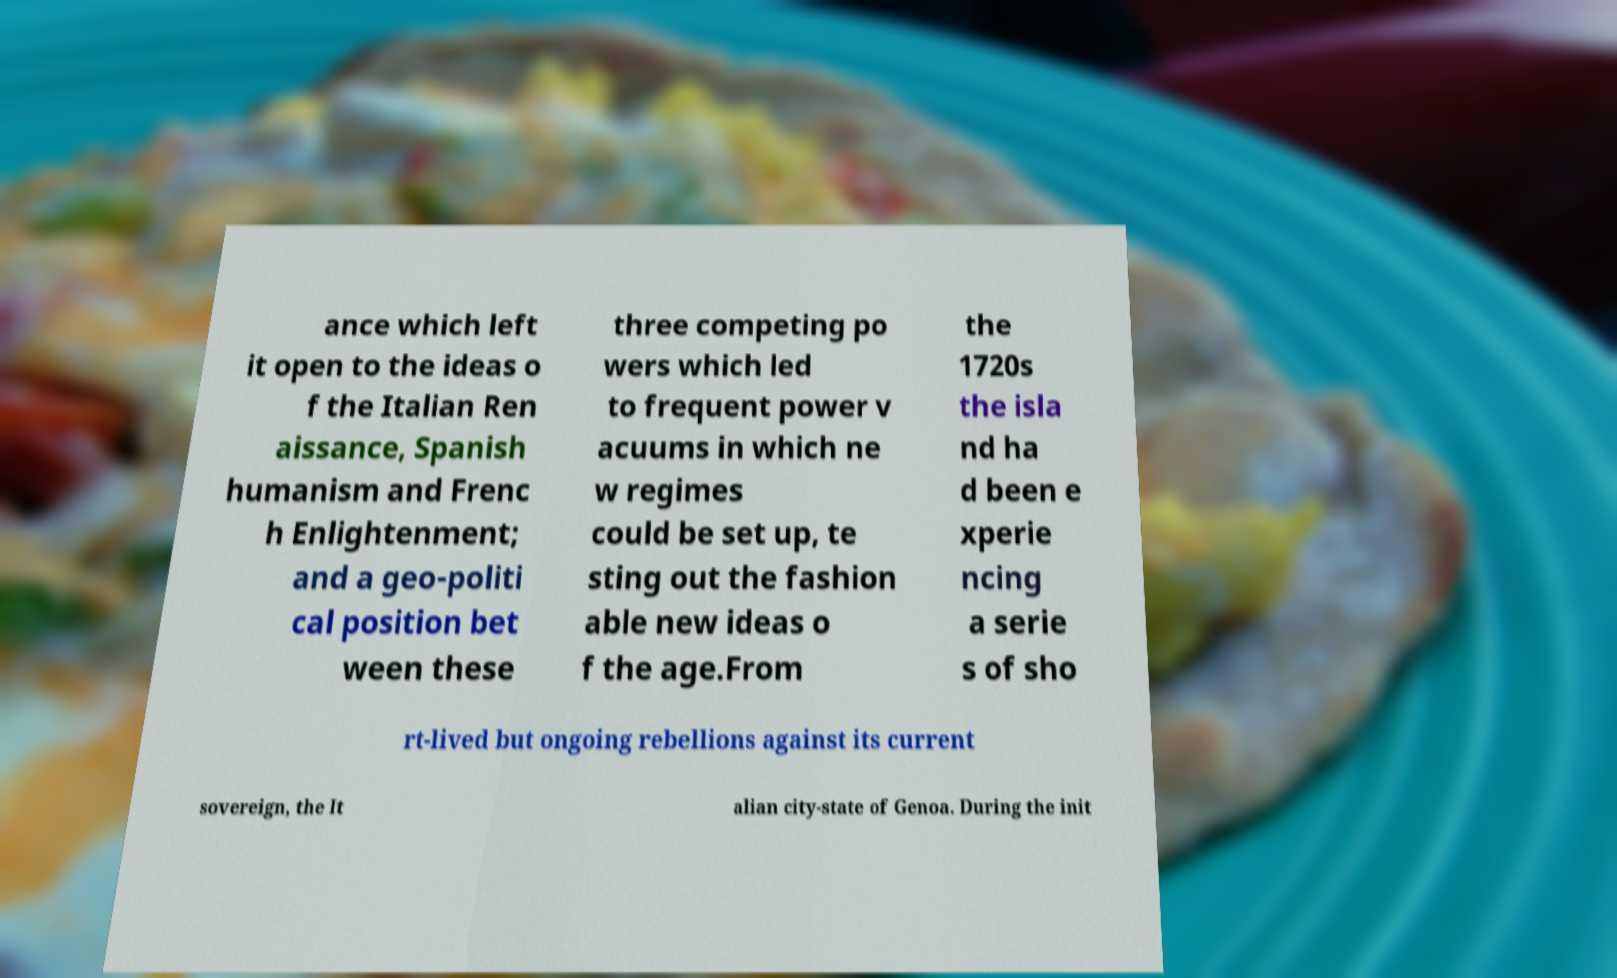Could you assist in decoding the text presented in this image and type it out clearly? ance which left it open to the ideas o f the Italian Ren aissance, Spanish humanism and Frenc h Enlightenment; and a geo-politi cal position bet ween these three competing po wers which led to frequent power v acuums in which ne w regimes could be set up, te sting out the fashion able new ideas o f the age.From the 1720s the isla nd ha d been e xperie ncing a serie s of sho rt-lived but ongoing rebellions against its current sovereign, the It alian city-state of Genoa. During the init 